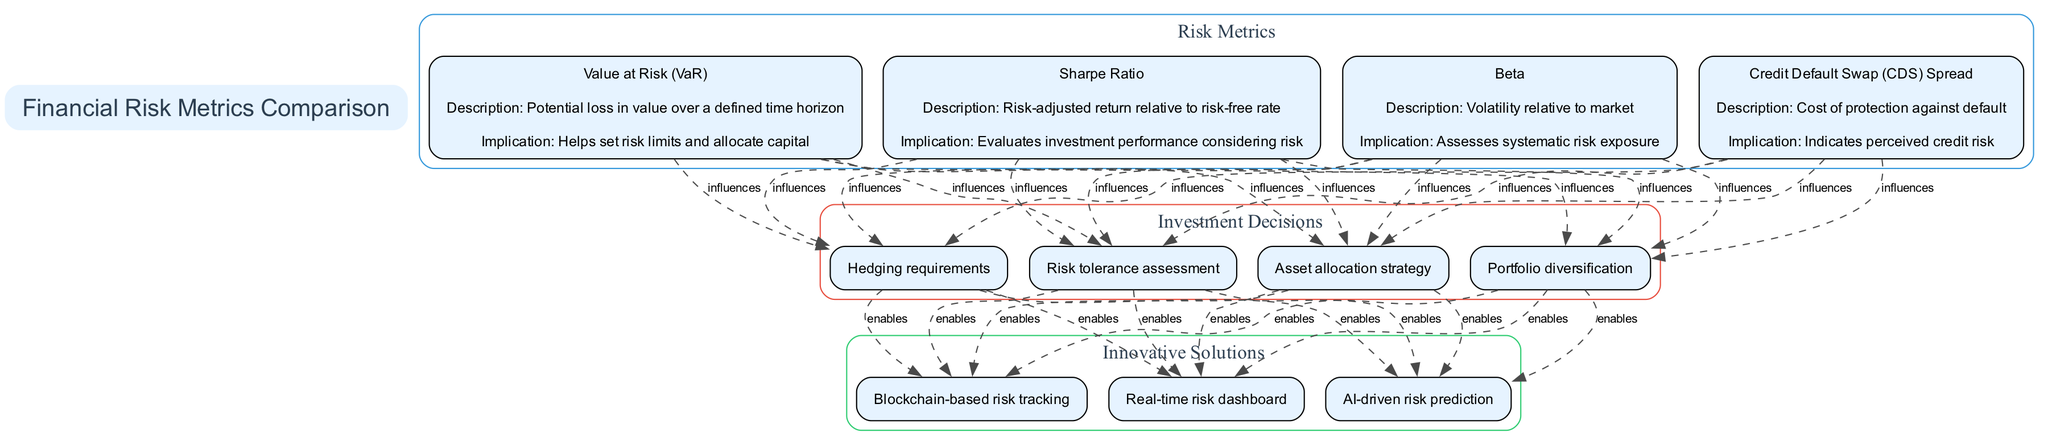What is the first metric listed in the diagram? The first metric is Value at Risk (VaR), as it is the first entry in the metrics section labeled "Risk Metrics."
Answer: Value at Risk (VaR) How many investment decisions are represented in the diagram? There are four investment decisions listed in the Investment Decisions section of the diagram.
Answer: 4 What does the Sharpe Ratio evaluate? The Sharpe Ratio evaluates investment performance considering risk, as described in its implications section.
Answer: Investment performance considering risk Which risk metric indicates perceived credit risk? The Credit Default Swap (CDS) Spread indicates perceived credit risk, as stated in its description.
Answer: Credit Default Swap (CDS) Spread How do the risk metrics influence the investment decisions? Each risk metric influences all four investment decisions, as shown by the dashed edges connecting them in the diagram.
Answer: All influence each What is the significance of the Beta metric? The Beta metric assesses systematic risk exposure, providing insight into how the asset's volatility relates to the broader market.
Answer: Assesses systematic risk exposure How many innovative solutions are connected to the investment decisions? Each of the four investment decisions is connected to all three innovative solutions as indicated by the edges drawn in the diagram.
Answer: 3 What type of relationship is depicted between metrics and investment decisions? The relationship is represented as influences with dashed lines indicating that metrics affect the decision-making process.
Answer: Influences Which innovative solution utilizes blockchain technology? The innovative solution that utilizes blockchain technology is "Blockchain-based risk tracking" mentioned in the solutions section.
Answer: Blockchain-based risk tracking 